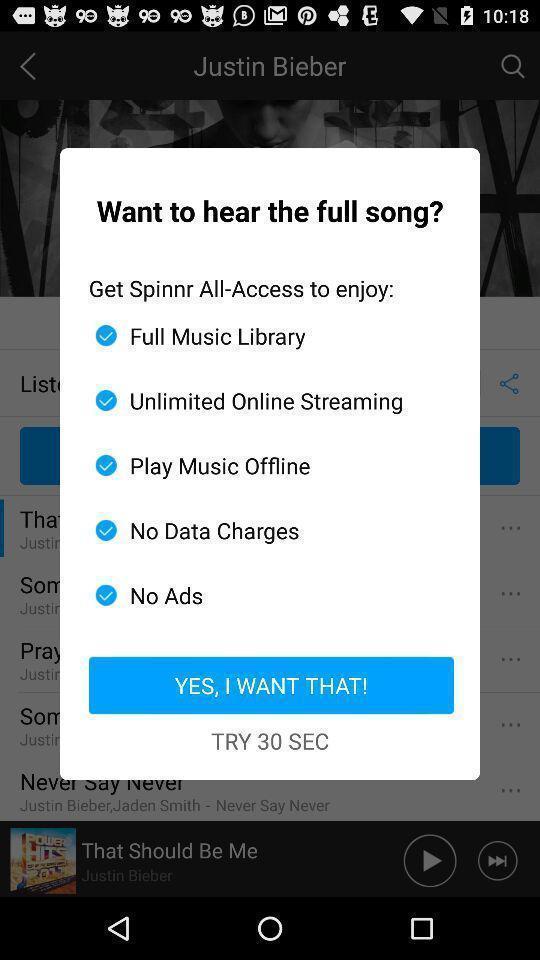What details can you identify in this image? Popup page for listening a song of a music app. 